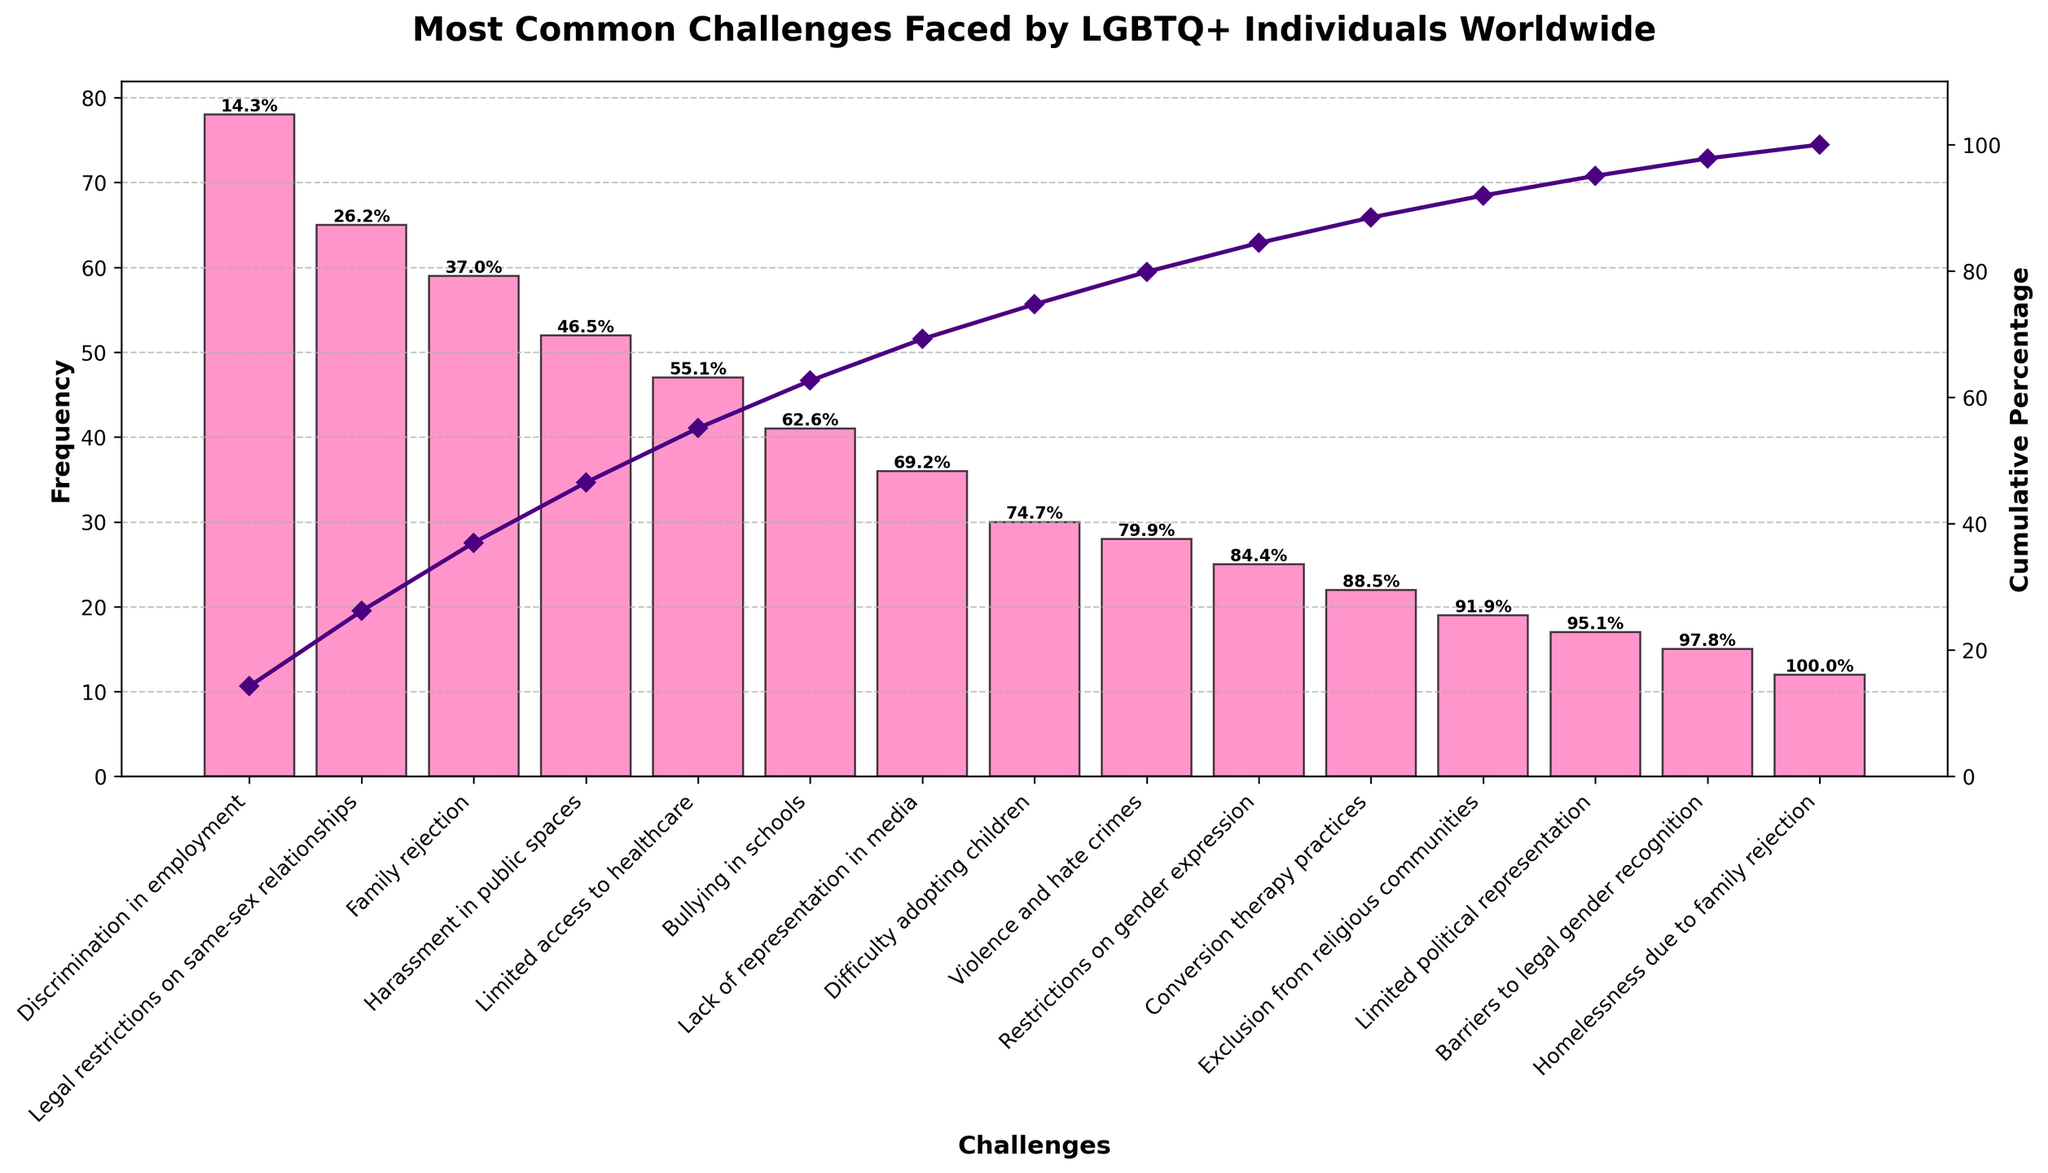What is the most common challenge faced by LGBTQ+ individuals worldwide according to the figure? The figure shows a bar chart where the height of each bar represents the frequency of different challenges. The highest bar corresponds to "Discrimination in employment."
Answer: Discrimination in employment What is the title of the figure? The title is usually located at the top of the figure and is clearly labeled. In this case, it is "Most Common Challenges Faced by LGBTQ+ Individuals Worldwide."
Answer: Most Common Challenges Faced by LGBTQ+ Individuals Worldwide Which challenge has the second-highest frequency? The second-highest bar in the chart corresponds to the second data point from the left, which is labeled as "Legal restrictions on same-sex relationships."
Answer: Legal restrictions on same-sex relationships How many challenges have a frequency greater than 30? By counting the bars taller than the 30-mark on the y-axis, we see that there are eight bars taller than this mark.
Answer: Eight What cumulative percentage of challenges is reached by "Bullying in schools"? Find the bar labeled "Bullying in schools" and read the cumulative percentage value associated with it. The value is shown above the bar; it is approximately 73.2%.
Answer: 73.2% How do the frequencies of "Harassment in public spaces" and "Limited access to healthcare" compare? Check the heights of the bars corresponding to these challenges. "Harassment in public spaces" has a frequency of 52, and "Limited access to healthcare" has a frequency of 47.
Answer: Harassment in public spaces is higher What is the cumulative percentage after "Bullying in schools" is added? Look at the cumulative percentage above the "Bullying in schools" bar in the chart. It shows approximately 73.2%.
Answer: 73.2% Which challenge has the lowest frequency, and what is it? Identify the shortest bar in the chart and read the label next to it. The shortest bar represents "Homelessness due to family rejection."
Answer: Homelessness due to family rejection 